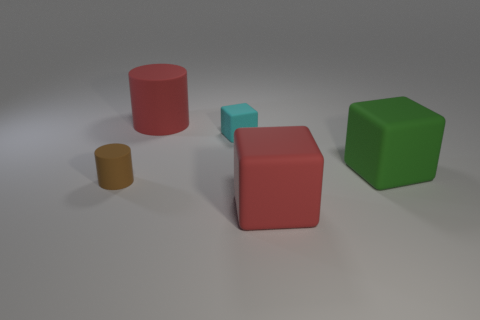Are there any other things that have the same color as the large matte cylinder?
Ensure brevity in your answer.  Yes. What number of tiny objects are in front of the small cube and behind the big green matte cube?
Ensure brevity in your answer.  0. Does the red thing left of the red block have the same size as the red matte thing on the right side of the cyan matte object?
Offer a very short reply. Yes. How many objects are big objects in front of the big cylinder or big red rubber spheres?
Give a very brief answer. 2. What is the tiny object to the left of the small cube made of?
Your answer should be compact. Rubber. What material is the red block?
Provide a succinct answer. Rubber. There is a red object that is in front of the rubber cylinder in front of the cylinder that is behind the tiny cyan thing; what is it made of?
Offer a very short reply. Rubber. Is there anything else that is made of the same material as the cyan object?
Offer a terse response. Yes. There is a green block; is its size the same as the matte cylinder that is in front of the large red rubber cylinder?
Your answer should be compact. No. What number of objects are rubber cubes that are behind the green object or tiny objects that are on the left side of the large red cylinder?
Ensure brevity in your answer.  2. 